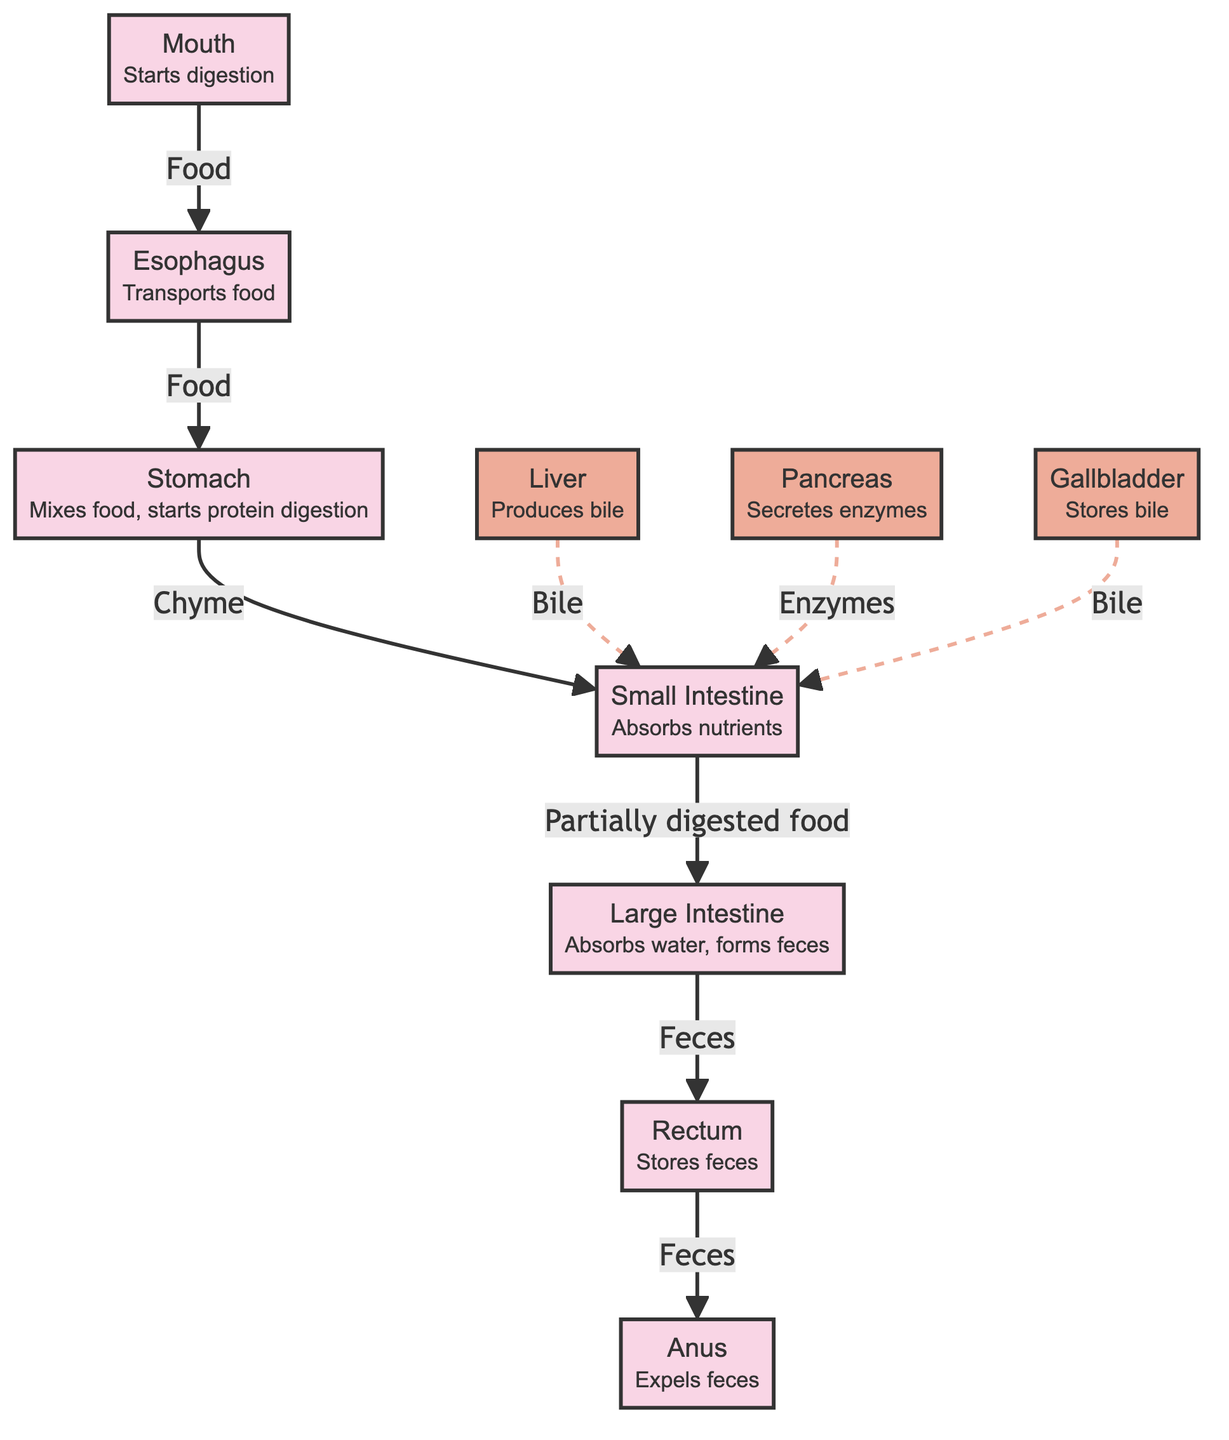What is the first organ in the digestive system? The diagram clearly shows the flow of food, starting from the mouth. Since it is the first in the series, it is indicated as the starting point of digestion.
Answer: Mouth How many total organs are represented in the digestive system diagram? By counting the nodes that are labeled as organs (mouth, esophagus, stomach, small intestine, large intestine, rectum, anus), there are 7 distinct organs shown.
Answer: 7 What substance does the liver produce? The diagram specifies that the liver produces bile. This is noted in its description, which points out the liver's function as related to bile production.
Answer: Bile What is the primary function of the large intestine? According to the diagram, the large intestine's designated function is to absorb water and form feces, as stated in its description.
Answer: Absorbs water, forms feces Which organ is responsible for secreting enzymes? The pancreas is identified in the diagram as the organ that secretes enzymes. This function is clearly stated in its description indicating its role in digestion.
Answer: Pancreas What type of flow is represented between the pancreas and the small intestine? The diagram indicates a dashed line for the flow from the pancreas to the small intestine, signifying that the enzymes are secreted rather than transported directly. Hence, this flow is represented as auxiliary.
Answer: Auxiliary Which organ directly follows the stomach in the digestion process? The diagram shows a clear flow from the stomach to the small intestine. Since the small intestine is the next organ in the sequence, this is the direct answer to the question.
Answer: Small Intestine What organ stores feces before expulsion? The diagram marks the rectum as the organ responsible for storing feces, which is detailed in its function description.
Answer: Rectum What role does the gallbladder play in the digestive system? The gallbladder is described in the diagram as storing bile, indicating its purpose in the digestive process connected directly to the liver and small intestine.
Answer: Stores bile 